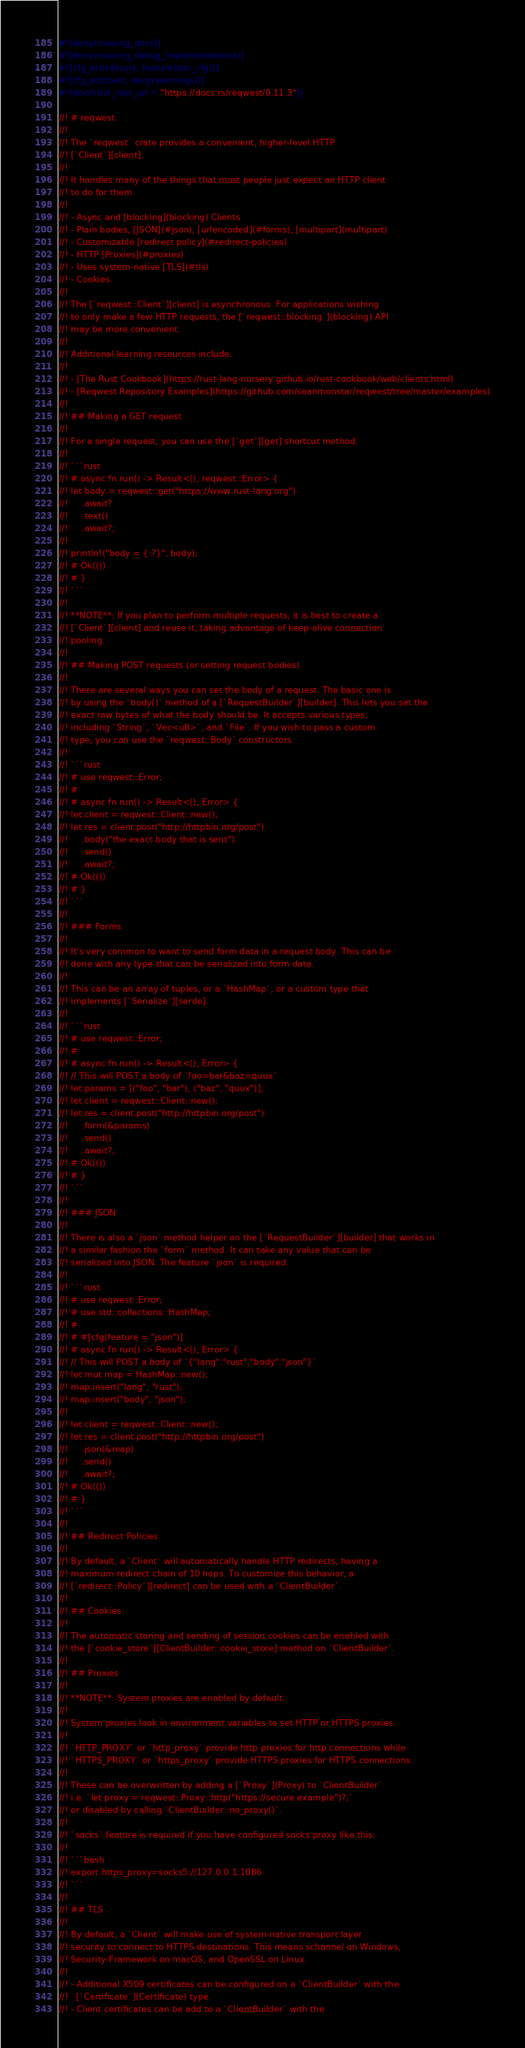<code> <loc_0><loc_0><loc_500><loc_500><_Rust_>#![deny(missing_docs)]
#![deny(missing_debug_implementations)]
#![cfg_attr(docsrs, feature(doc_cfg))]
#![cfg_attr(test, deny(warnings))]
#![doc(html_root_url = "https://docs.rs/reqwest/0.11.3")]

//! # reqwest
//!
//! The `reqwest` crate provides a convenient, higher-level HTTP
//! [`Client`][client].
//!
//! It handles many of the things that most people just expect an HTTP client
//! to do for them.
//!
//! - Async and [blocking](blocking) Clients
//! - Plain bodies, [JSON](#json), [urlencoded](#forms), [multipart](multipart)
//! - Customizable [redirect policy](#redirect-policies)
//! - HTTP [Proxies](#proxies)
//! - Uses system-native [TLS](#tls)
//! - Cookies
//!
//! The [`reqwest::Client`][client] is asynchronous. For applications wishing
//! to only make a few HTTP requests, the [`reqwest::blocking`](blocking) API
//! may be more convenient.
//!
//! Additional learning resources include:
//!
//! - [The Rust Cookbook](https://rust-lang-nursery.github.io/rust-cookbook/web/clients.html)
//! - [Reqwest Repository Examples](https://github.com/seanmonstar/reqwest/tree/master/examples)
//!
//! ## Making a GET request
//!
//! For a single request, you can use the [`get`][get] shortcut method.
//!
//! ```rust
//! # async fn run() -> Result<(), reqwest::Error> {
//! let body = reqwest::get("https://www.rust-lang.org")
//!     .await?
//!     .text()
//!     .await?;
//!
//! println!("body = {:?}", body);
//! # Ok(())
//! # }
//! ```
//!
//! **NOTE**: If you plan to perform multiple requests, it is best to create a
//! [`Client`][client] and reuse it, taking advantage of keep-alive connection
//! pooling.
//!
//! ## Making POST requests (or setting request bodies)
//!
//! There are several ways you can set the body of a request. The basic one is
//! by using the `body()` method of a [`RequestBuilder`][builder]. This lets you set the
//! exact raw bytes of what the body should be. It accepts various types,
//! including `String`, `Vec<u8>`, and `File`. If you wish to pass a custom
//! type, you can use the `reqwest::Body` constructors.
//!
//! ```rust
//! # use reqwest::Error;
//! #
//! # async fn run() -> Result<(), Error> {
//! let client = reqwest::Client::new();
//! let res = client.post("http://httpbin.org/post")
//!     .body("the exact body that is sent")
//!     .send()
//!     .await?;
//! # Ok(())
//! # }
//! ```
//!
//! ### Forms
//!
//! It's very common to want to send form data in a request body. This can be
//! done with any type that can be serialized into form data.
//!
//! This can be an array of tuples, or a `HashMap`, or a custom type that
//! implements [`Serialize`][serde].
//!
//! ```rust
//! # use reqwest::Error;
//! #
//! # async fn run() -> Result<(), Error> {
//! // This will POST a body of `foo=bar&baz=quux`
//! let params = [("foo", "bar"), ("baz", "quux")];
//! let client = reqwest::Client::new();
//! let res = client.post("http://httpbin.org/post")
//!     .form(&params)
//!     .send()
//!     .await?;
//! # Ok(())
//! # }
//! ```
//!
//! ### JSON
//!
//! There is also a `json` method helper on the [`RequestBuilder`][builder] that works in
//! a similar fashion the `form` method. It can take any value that can be
//! serialized into JSON. The feature `json` is required.
//!
//! ```rust
//! # use reqwest::Error;
//! # use std::collections::HashMap;
//! #
//! # #[cfg(feature = "json")]
//! # async fn run() -> Result<(), Error> {
//! // This will POST a body of `{"lang":"rust","body":"json"}`
//! let mut map = HashMap::new();
//! map.insert("lang", "rust");
//! map.insert("body", "json");
//!
//! let client = reqwest::Client::new();
//! let res = client.post("http://httpbin.org/post")
//!     .json(&map)
//!     .send()
//!     .await?;
//! # Ok(())
//! # }
//! ```
//!
//! ## Redirect Policies
//!
//! By default, a `Client` will automatically handle HTTP redirects, having a
//! maximum redirect chain of 10 hops. To customize this behavior, a
//! [`redirect::Policy`][redirect] can be used with a `ClientBuilder`.
//!
//! ## Cookies
//!
//! The automatic storing and sending of session cookies can be enabled with
//! the [`cookie_store`][ClientBuilder::cookie_store] method on `ClientBuilder`.
//!
//! ## Proxies
//!
//! **NOTE**: System proxies are enabled by default.
//!
//! System proxies look in environment variables to set HTTP or HTTPS proxies.
//!
//! `HTTP_PROXY` or `http_proxy` provide http proxies for http connections while
//! `HTTPS_PROXY` or `https_proxy` provide HTTPS proxies for HTTPS connections.
//!
//! These can be overwritten by adding a [`Proxy`](Proxy) to `ClientBuilder`
//! i.e. `let proxy = reqwest::Proxy::http("https://secure.example")?;`
//! or disabled by calling `ClientBuilder::no_proxy()`.
//!
//! `socks` feature is required if you have configured socks proxy like this:
//!
//! ```bash
//! export https_proxy=socks5://127.0.0.1:1086
//! ```
//!
//! ## TLS
//!
//! By default, a `Client` will make use of system-native transport layer
//! security to connect to HTTPS destinations. This means schannel on Windows,
//! Security-Framework on macOS, and OpenSSL on Linux.
//!
//! - Additional X509 certificates can be configured on a `ClientBuilder` with the
//!   [`Certificate`](Certificate) type.
//! - Client certificates can be add to a `ClientBuilder` with the</code> 